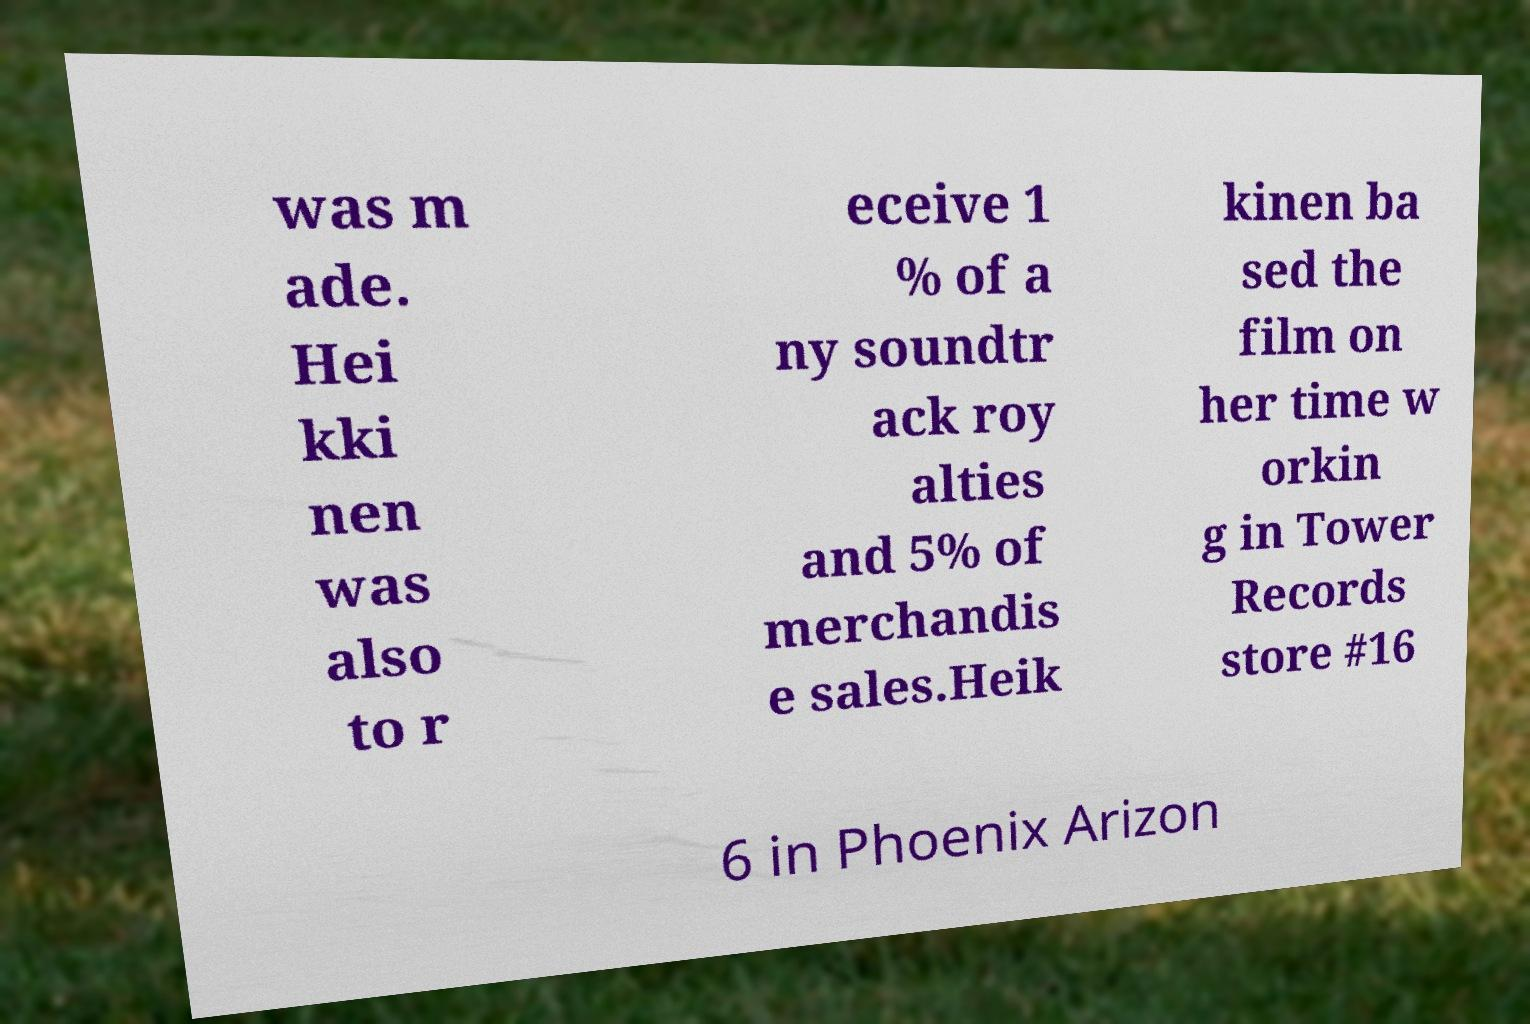Please read and relay the text visible in this image. What does it say? was m ade. Hei kki nen was also to r eceive 1 % of a ny soundtr ack roy alties and 5% of merchandis e sales.Heik kinen ba sed the film on her time w orkin g in Tower Records store #16 6 in Phoenix Arizon 